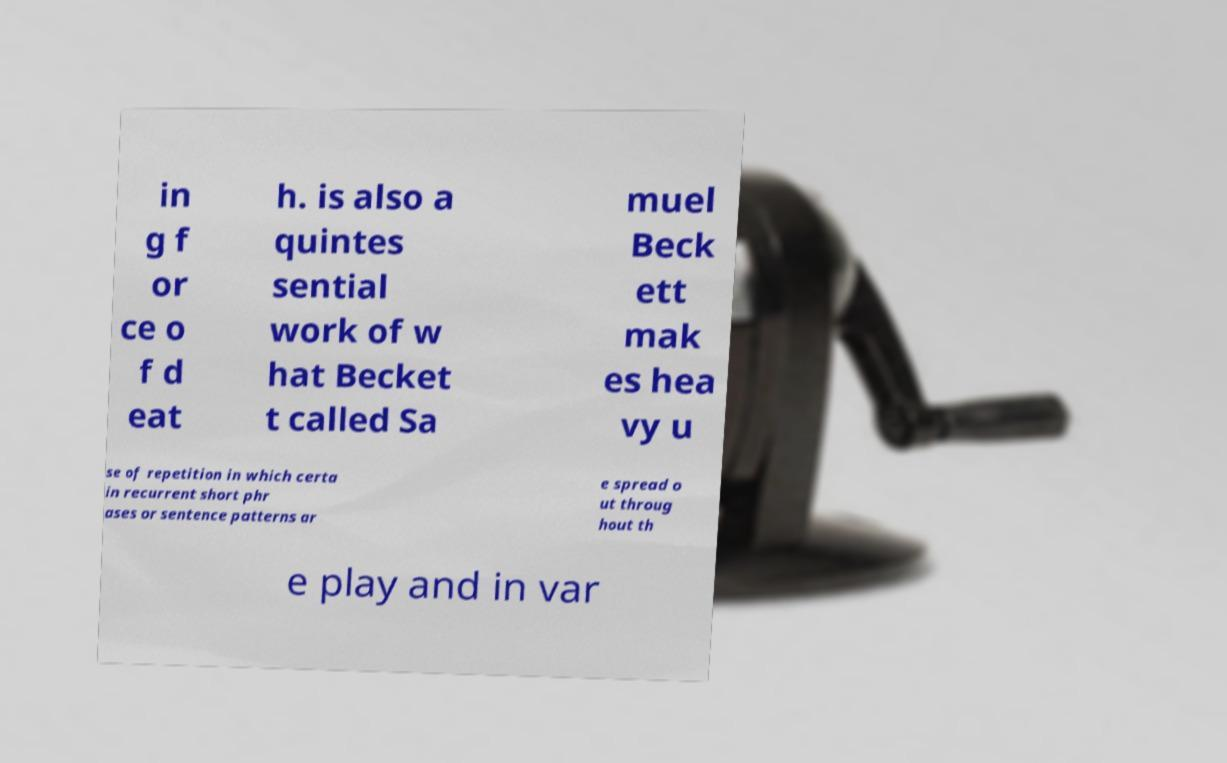There's text embedded in this image that I need extracted. Can you transcribe it verbatim? in g f or ce o f d eat h. is also a quintes sential work of w hat Becket t called Sa muel Beck ett mak es hea vy u se of repetition in which certa in recurrent short phr ases or sentence patterns ar e spread o ut throug hout th e play and in var 